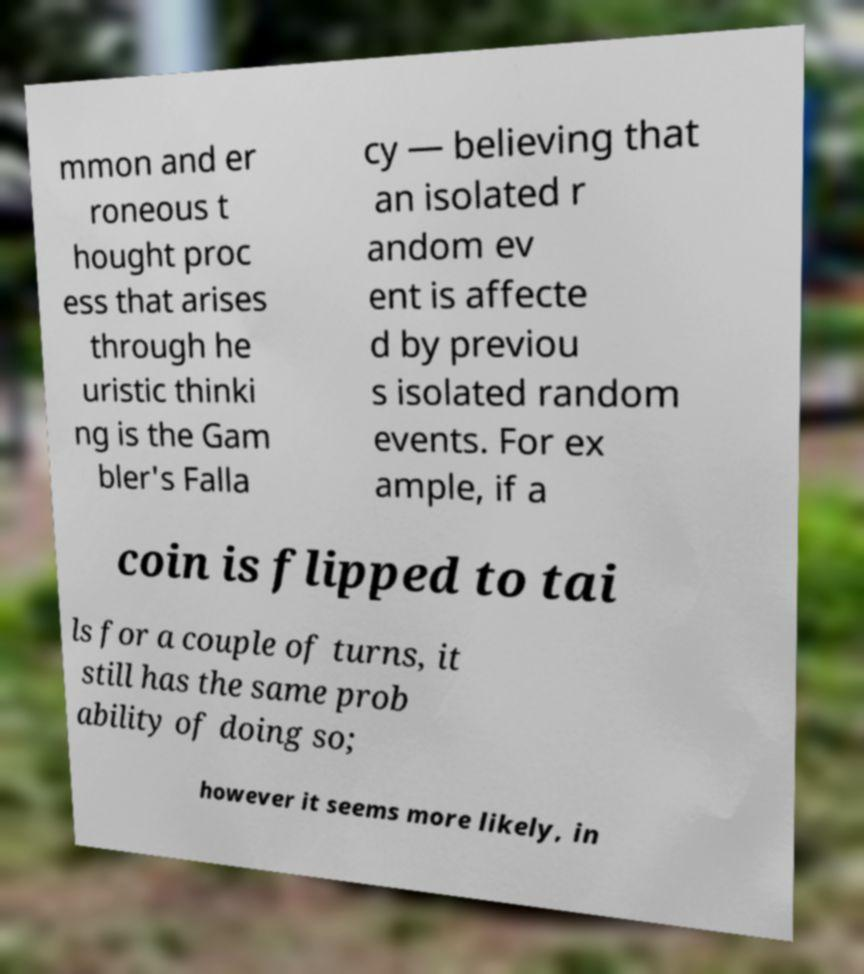I need the written content from this picture converted into text. Can you do that? mmon and er roneous t hought proc ess that arises through he uristic thinki ng is the Gam bler's Falla cy — believing that an isolated r andom ev ent is affecte d by previou s isolated random events. For ex ample, if a coin is flipped to tai ls for a couple of turns, it still has the same prob ability of doing so; however it seems more likely, in 